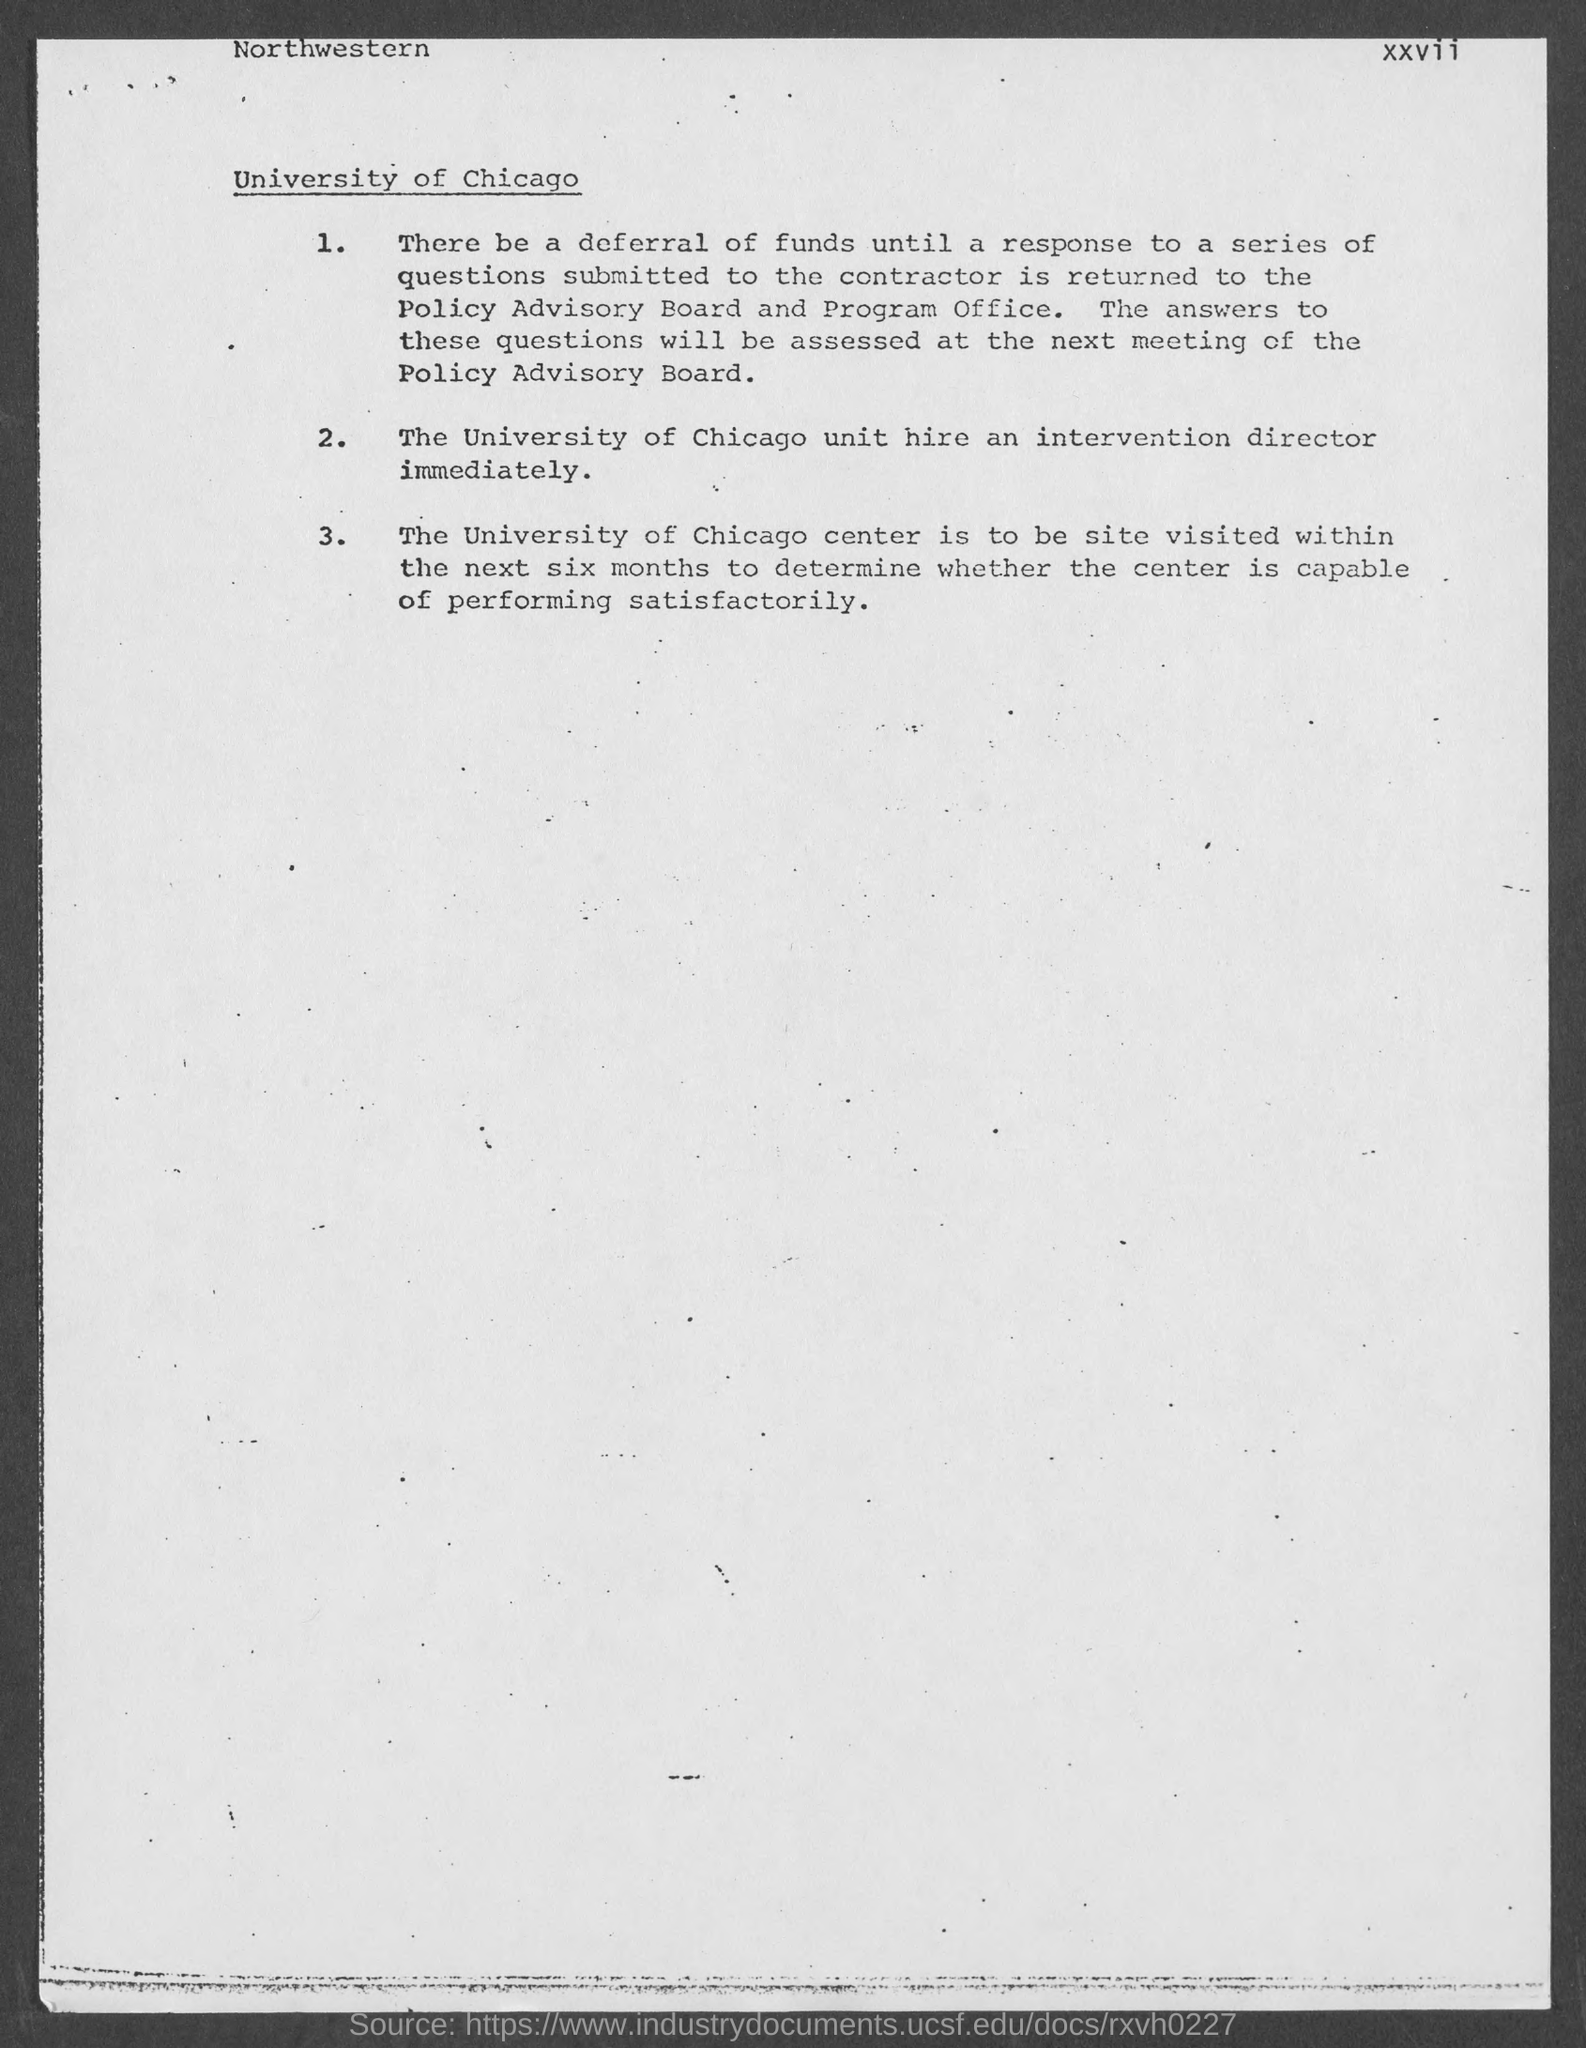What is the page number?
Provide a succinct answer. Xxvii. What is the title of the document?
Your answer should be compact. University of Chicago. Which text is at the top-left of the document?
Offer a very short reply. Northwestern. 